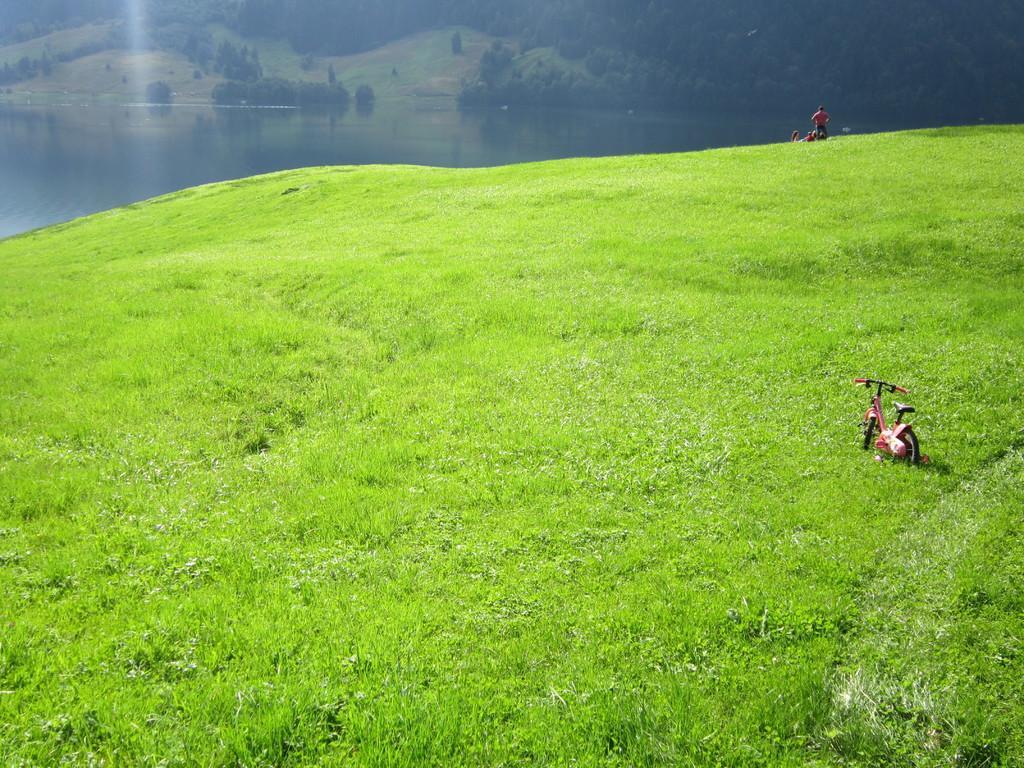Can you describe this image briefly? In this image there is a vehicle and a person on the grass, there are few trees and water. 